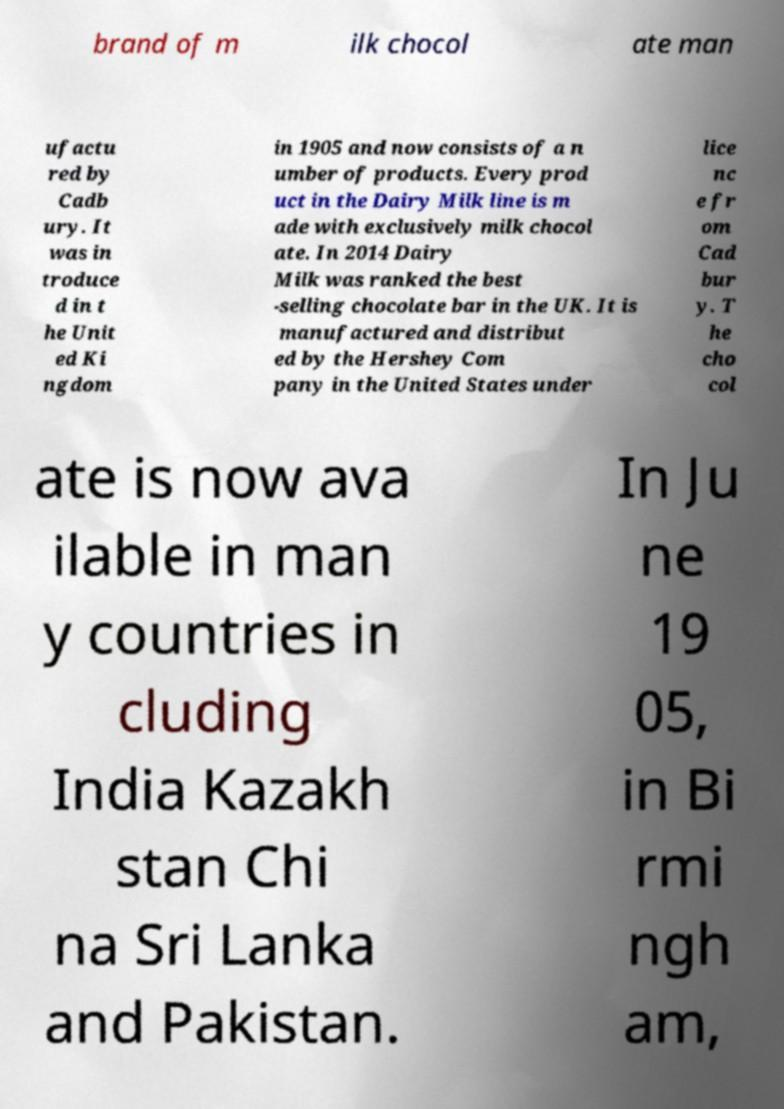For documentation purposes, I need the text within this image transcribed. Could you provide that? brand of m ilk chocol ate man ufactu red by Cadb ury. It was in troduce d in t he Unit ed Ki ngdom in 1905 and now consists of a n umber of products. Every prod uct in the Dairy Milk line is m ade with exclusively milk chocol ate. In 2014 Dairy Milk was ranked the best -selling chocolate bar in the UK. It is manufactured and distribut ed by the Hershey Com pany in the United States under lice nc e fr om Cad bur y. T he cho col ate is now ava ilable in man y countries in cluding India Kazakh stan Chi na Sri Lanka and Pakistan. In Ju ne 19 05, in Bi rmi ngh am, 